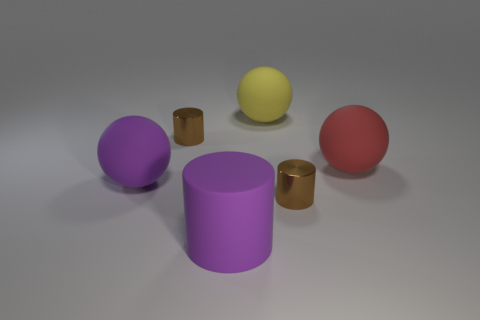What number of other metallic objects have the same shape as the red object?
Ensure brevity in your answer.  0. What is the purple cylinder made of?
Keep it short and to the point. Rubber. There is a rubber cylinder; is its color the same as the small thing that is behind the large red matte thing?
Make the answer very short. No. How many spheres are large yellow matte objects or brown things?
Your response must be concise. 1. There is a matte sphere in front of the big red rubber thing; what is its color?
Make the answer very short. Purple. What number of purple rubber objects have the same size as the yellow matte sphere?
Your response must be concise. 2. There is a tiny brown thing behind the red ball; does it have the same shape as the rubber thing that is behind the red sphere?
Provide a succinct answer. No. There is a yellow thing that is behind the tiny thing that is left of the small brown cylinder that is in front of the big red thing; what is its material?
Your response must be concise. Rubber. What shape is the purple rubber object that is the same size as the purple cylinder?
Your response must be concise. Sphere. Is there another large rubber cylinder that has the same color as the big cylinder?
Keep it short and to the point. No. 